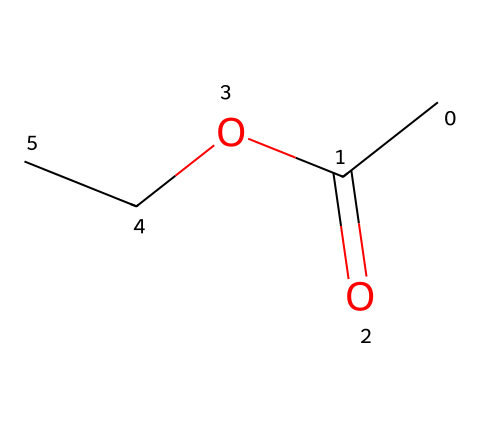What is the functional group present in ethyl acetate? The chemical structure shows a carbonyl group (C=O) and an ester bond (C-O), recognizable by the -COO- part of the molecule.
Answer: ester How many carbon atoms are in ethyl acetate? Analyzing the structure, there are three carbon atoms in total: one from the acetyl group (C=O) and two from the ethyl group (OCC).
Answer: three What is the total number of hydrogen atoms in ethyl acetate? By examining the structure: the three carbon atoms can be connected to a maximum of eight hydrogens (C3H8), but considering the presence of double bond and single bonds, the total number of hydrogens equals five.
Answer: five What type of reaction typically forms ethyl acetate? Ethyl acetate is commonly formed through a condensation reaction between acetic acid and ethanol, resulting in ester formation.
Answer: condensation What property of ethyl acetate makes it useful as a solvent? Its relatively low molecular weight and polarity allow it to dissolve many organic compounds efficiently, making it effective as a solvent.
Answer: polarity How many oxygen atoms are present in ethyl acetate? The structure reveals there are two oxygen atoms: one from the carbonyl functional group (C=O) and another from the ether part (OCC).
Answer: two What makes ethyl acetate a volatiles substance? The presence of the ester functional group contributes to lower boiling points compared to higher molecular weight compounds, which makes it volatile.
Answer: low boiling point 